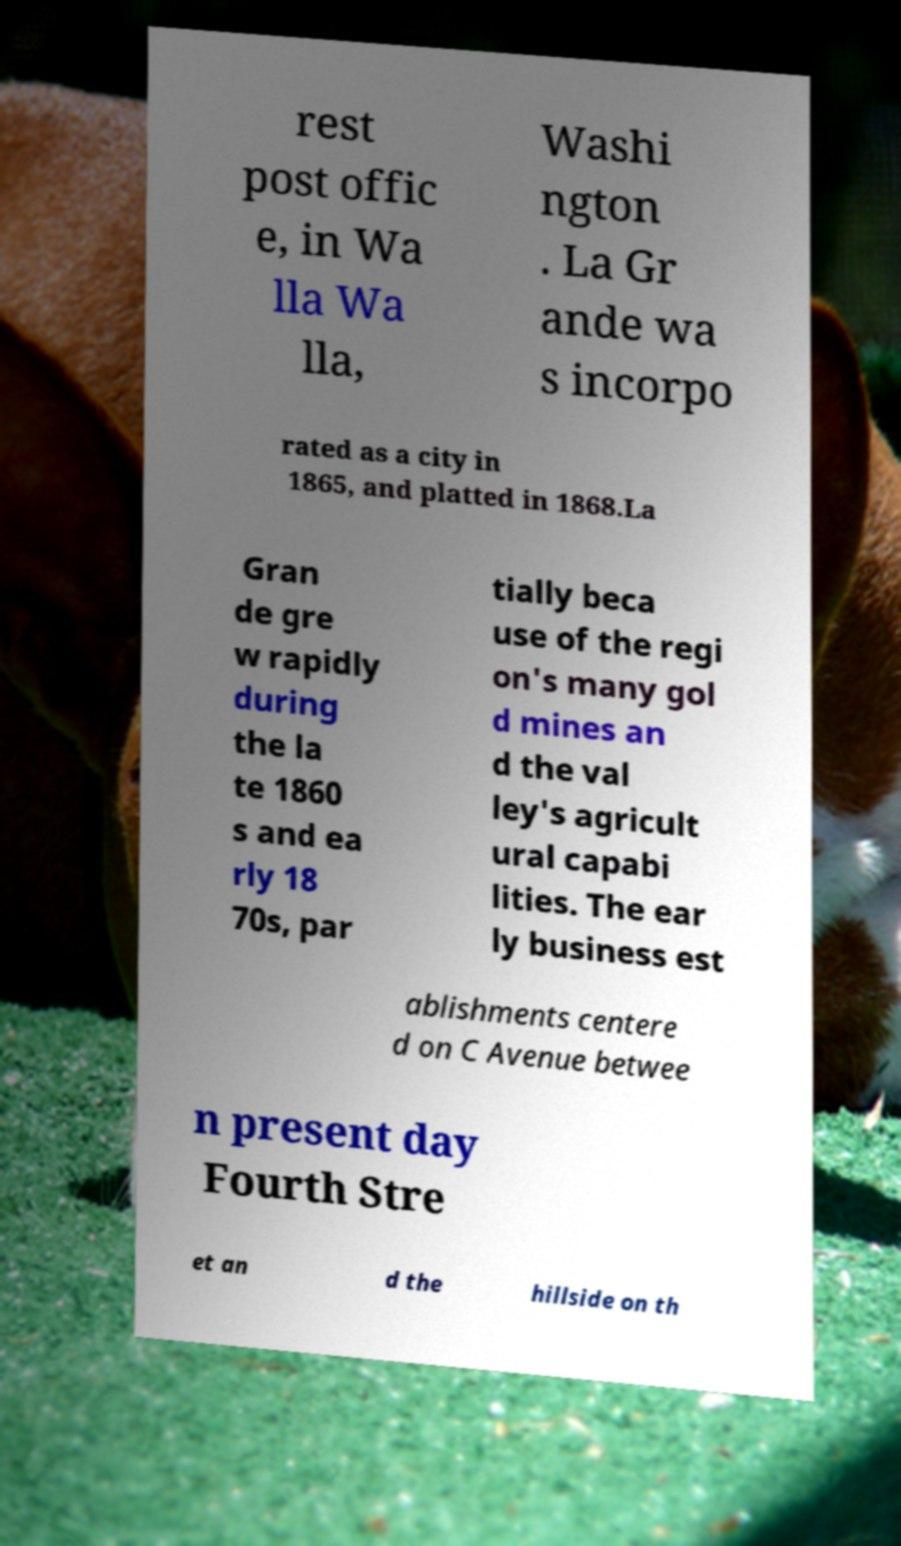Can you accurately transcribe the text from the provided image for me? rest post offic e, in Wa lla Wa lla, Washi ngton . La Gr ande wa s incorpo rated as a city in 1865, and platted in 1868.La Gran de gre w rapidly during the la te 1860 s and ea rly 18 70s, par tially beca use of the regi on's many gol d mines an d the val ley's agricult ural capabi lities. The ear ly business est ablishments centere d on C Avenue betwee n present day Fourth Stre et an d the hillside on th 